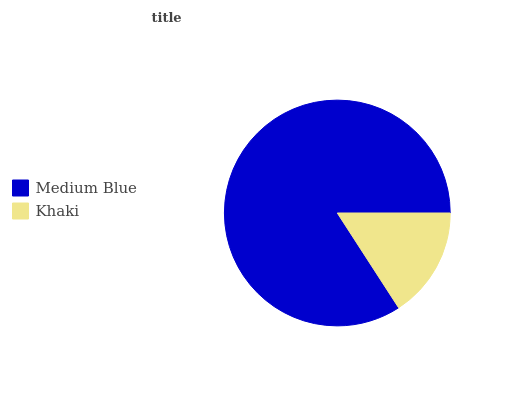Is Khaki the minimum?
Answer yes or no. Yes. Is Medium Blue the maximum?
Answer yes or no. Yes. Is Khaki the maximum?
Answer yes or no. No. Is Medium Blue greater than Khaki?
Answer yes or no. Yes. Is Khaki less than Medium Blue?
Answer yes or no. Yes. Is Khaki greater than Medium Blue?
Answer yes or no. No. Is Medium Blue less than Khaki?
Answer yes or no. No. Is Medium Blue the high median?
Answer yes or no. Yes. Is Khaki the low median?
Answer yes or no. Yes. Is Khaki the high median?
Answer yes or no. No. Is Medium Blue the low median?
Answer yes or no. No. 